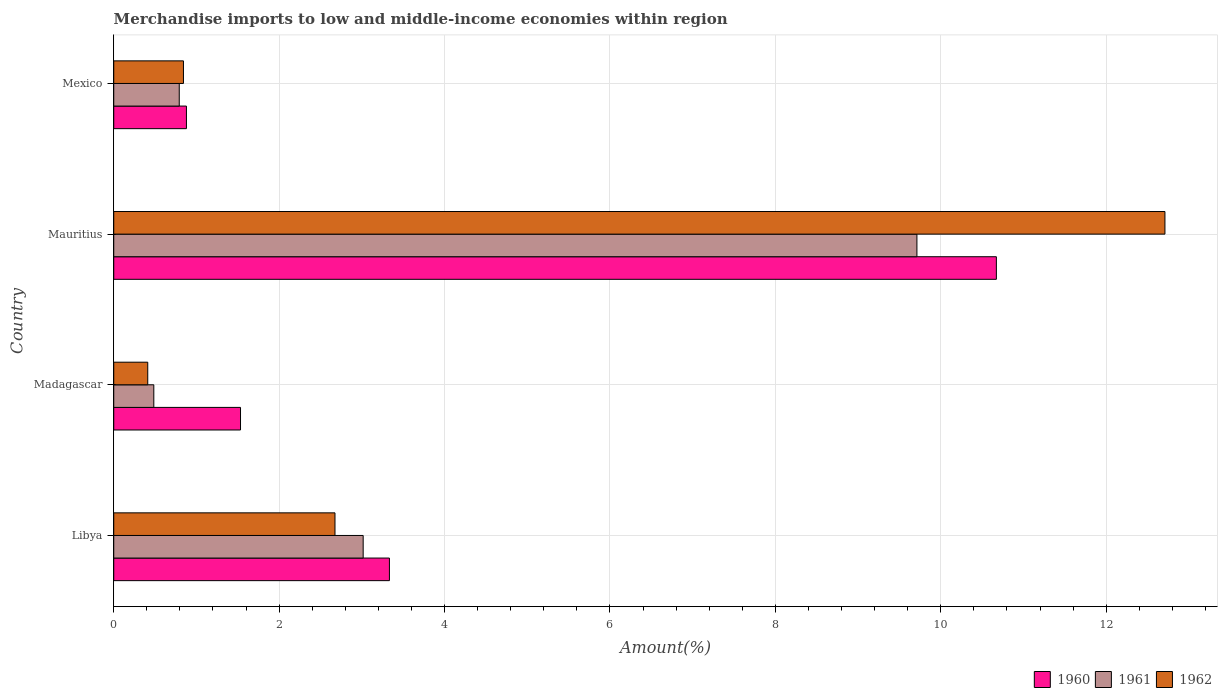How many groups of bars are there?
Offer a very short reply. 4. Are the number of bars per tick equal to the number of legend labels?
Your answer should be compact. Yes. Are the number of bars on each tick of the Y-axis equal?
Offer a very short reply. Yes. How many bars are there on the 4th tick from the top?
Your answer should be compact. 3. How many bars are there on the 4th tick from the bottom?
Provide a short and direct response. 3. What is the label of the 2nd group of bars from the top?
Your answer should be compact. Mauritius. In how many cases, is the number of bars for a given country not equal to the number of legend labels?
Keep it short and to the point. 0. What is the percentage of amount earned from merchandise imports in 1962 in Mexico?
Your response must be concise. 0.84. Across all countries, what is the maximum percentage of amount earned from merchandise imports in 1961?
Your answer should be very brief. 9.71. Across all countries, what is the minimum percentage of amount earned from merchandise imports in 1961?
Your answer should be very brief. 0.48. In which country was the percentage of amount earned from merchandise imports in 1960 maximum?
Provide a succinct answer. Mauritius. In which country was the percentage of amount earned from merchandise imports in 1960 minimum?
Your answer should be compact. Mexico. What is the total percentage of amount earned from merchandise imports in 1961 in the graph?
Offer a terse response. 14. What is the difference between the percentage of amount earned from merchandise imports in 1962 in Madagascar and that in Mauritius?
Your answer should be very brief. -12.3. What is the difference between the percentage of amount earned from merchandise imports in 1961 in Mauritius and the percentage of amount earned from merchandise imports in 1960 in Mexico?
Offer a very short reply. 8.83. What is the average percentage of amount earned from merchandise imports in 1961 per country?
Your answer should be very brief. 3.5. What is the difference between the percentage of amount earned from merchandise imports in 1962 and percentage of amount earned from merchandise imports in 1961 in Mexico?
Your answer should be compact. 0.05. In how many countries, is the percentage of amount earned from merchandise imports in 1960 greater than 6.8 %?
Your answer should be compact. 1. What is the ratio of the percentage of amount earned from merchandise imports in 1961 in Libya to that in Madagascar?
Provide a short and direct response. 6.23. Is the percentage of amount earned from merchandise imports in 1962 in Mauritius less than that in Mexico?
Give a very brief answer. No. Is the difference between the percentage of amount earned from merchandise imports in 1962 in Libya and Madagascar greater than the difference between the percentage of amount earned from merchandise imports in 1961 in Libya and Madagascar?
Offer a terse response. No. What is the difference between the highest and the second highest percentage of amount earned from merchandise imports in 1962?
Ensure brevity in your answer.  10.04. What is the difference between the highest and the lowest percentage of amount earned from merchandise imports in 1962?
Keep it short and to the point. 12.3. Is the sum of the percentage of amount earned from merchandise imports in 1962 in Mauritius and Mexico greater than the maximum percentage of amount earned from merchandise imports in 1961 across all countries?
Keep it short and to the point. Yes. What does the 3rd bar from the top in Libya represents?
Keep it short and to the point. 1960. What does the 1st bar from the bottom in Libya represents?
Your answer should be compact. 1960. Are all the bars in the graph horizontal?
Your answer should be compact. Yes. What is the difference between two consecutive major ticks on the X-axis?
Make the answer very short. 2. Are the values on the major ticks of X-axis written in scientific E-notation?
Your answer should be compact. No. Does the graph contain any zero values?
Offer a very short reply. No. Where does the legend appear in the graph?
Offer a terse response. Bottom right. How many legend labels are there?
Keep it short and to the point. 3. What is the title of the graph?
Your response must be concise. Merchandise imports to low and middle-income economies within region. What is the label or title of the X-axis?
Ensure brevity in your answer.  Amount(%). What is the Amount(%) of 1960 in Libya?
Your answer should be compact. 3.33. What is the Amount(%) of 1961 in Libya?
Make the answer very short. 3.02. What is the Amount(%) of 1962 in Libya?
Your response must be concise. 2.68. What is the Amount(%) of 1960 in Madagascar?
Provide a succinct answer. 1.53. What is the Amount(%) in 1961 in Madagascar?
Give a very brief answer. 0.48. What is the Amount(%) in 1962 in Madagascar?
Make the answer very short. 0.41. What is the Amount(%) of 1960 in Mauritius?
Give a very brief answer. 10.67. What is the Amount(%) in 1961 in Mauritius?
Your answer should be compact. 9.71. What is the Amount(%) of 1962 in Mauritius?
Your response must be concise. 12.71. What is the Amount(%) of 1960 in Mexico?
Your response must be concise. 0.88. What is the Amount(%) of 1961 in Mexico?
Ensure brevity in your answer.  0.79. What is the Amount(%) of 1962 in Mexico?
Offer a very short reply. 0.84. Across all countries, what is the maximum Amount(%) in 1960?
Provide a succinct answer. 10.67. Across all countries, what is the maximum Amount(%) in 1961?
Your answer should be compact. 9.71. Across all countries, what is the maximum Amount(%) in 1962?
Offer a very short reply. 12.71. Across all countries, what is the minimum Amount(%) of 1960?
Provide a short and direct response. 0.88. Across all countries, what is the minimum Amount(%) in 1961?
Offer a terse response. 0.48. Across all countries, what is the minimum Amount(%) in 1962?
Make the answer very short. 0.41. What is the total Amount(%) in 1960 in the graph?
Your answer should be very brief. 16.42. What is the total Amount(%) in 1961 in the graph?
Make the answer very short. 14. What is the total Amount(%) of 1962 in the graph?
Your answer should be very brief. 16.64. What is the difference between the Amount(%) in 1960 in Libya and that in Madagascar?
Give a very brief answer. 1.8. What is the difference between the Amount(%) of 1961 in Libya and that in Madagascar?
Your response must be concise. 2.53. What is the difference between the Amount(%) of 1962 in Libya and that in Madagascar?
Your answer should be very brief. 2.26. What is the difference between the Amount(%) in 1960 in Libya and that in Mauritius?
Ensure brevity in your answer.  -7.34. What is the difference between the Amount(%) in 1961 in Libya and that in Mauritius?
Make the answer very short. -6.7. What is the difference between the Amount(%) of 1962 in Libya and that in Mauritius?
Offer a terse response. -10.04. What is the difference between the Amount(%) of 1960 in Libya and that in Mexico?
Your response must be concise. 2.45. What is the difference between the Amount(%) of 1961 in Libya and that in Mexico?
Offer a very short reply. 2.22. What is the difference between the Amount(%) of 1962 in Libya and that in Mexico?
Keep it short and to the point. 1.83. What is the difference between the Amount(%) in 1960 in Madagascar and that in Mauritius?
Your answer should be compact. -9.14. What is the difference between the Amount(%) of 1961 in Madagascar and that in Mauritius?
Your answer should be very brief. -9.23. What is the difference between the Amount(%) in 1962 in Madagascar and that in Mauritius?
Offer a terse response. -12.3. What is the difference between the Amount(%) in 1960 in Madagascar and that in Mexico?
Offer a very short reply. 0.65. What is the difference between the Amount(%) in 1961 in Madagascar and that in Mexico?
Provide a short and direct response. -0.31. What is the difference between the Amount(%) in 1962 in Madagascar and that in Mexico?
Your response must be concise. -0.43. What is the difference between the Amount(%) of 1960 in Mauritius and that in Mexico?
Your response must be concise. 9.79. What is the difference between the Amount(%) of 1961 in Mauritius and that in Mexico?
Your response must be concise. 8.92. What is the difference between the Amount(%) in 1962 in Mauritius and that in Mexico?
Give a very brief answer. 11.87. What is the difference between the Amount(%) of 1960 in Libya and the Amount(%) of 1961 in Madagascar?
Your answer should be very brief. 2.85. What is the difference between the Amount(%) in 1960 in Libya and the Amount(%) in 1962 in Madagascar?
Ensure brevity in your answer.  2.92. What is the difference between the Amount(%) in 1961 in Libya and the Amount(%) in 1962 in Madagascar?
Provide a short and direct response. 2.6. What is the difference between the Amount(%) of 1960 in Libya and the Amount(%) of 1961 in Mauritius?
Keep it short and to the point. -6.38. What is the difference between the Amount(%) of 1960 in Libya and the Amount(%) of 1962 in Mauritius?
Give a very brief answer. -9.38. What is the difference between the Amount(%) of 1961 in Libya and the Amount(%) of 1962 in Mauritius?
Your answer should be very brief. -9.69. What is the difference between the Amount(%) in 1960 in Libya and the Amount(%) in 1961 in Mexico?
Provide a short and direct response. 2.54. What is the difference between the Amount(%) of 1960 in Libya and the Amount(%) of 1962 in Mexico?
Provide a short and direct response. 2.49. What is the difference between the Amount(%) of 1961 in Libya and the Amount(%) of 1962 in Mexico?
Your answer should be compact. 2.17. What is the difference between the Amount(%) in 1960 in Madagascar and the Amount(%) in 1961 in Mauritius?
Make the answer very short. -8.18. What is the difference between the Amount(%) of 1960 in Madagascar and the Amount(%) of 1962 in Mauritius?
Provide a short and direct response. -11.18. What is the difference between the Amount(%) of 1961 in Madagascar and the Amount(%) of 1962 in Mauritius?
Your answer should be compact. -12.23. What is the difference between the Amount(%) of 1960 in Madagascar and the Amount(%) of 1961 in Mexico?
Give a very brief answer. 0.74. What is the difference between the Amount(%) of 1960 in Madagascar and the Amount(%) of 1962 in Mexico?
Give a very brief answer. 0.69. What is the difference between the Amount(%) in 1961 in Madagascar and the Amount(%) in 1962 in Mexico?
Your answer should be very brief. -0.36. What is the difference between the Amount(%) of 1960 in Mauritius and the Amount(%) of 1961 in Mexico?
Provide a short and direct response. 9.88. What is the difference between the Amount(%) in 1960 in Mauritius and the Amount(%) in 1962 in Mexico?
Provide a short and direct response. 9.83. What is the difference between the Amount(%) in 1961 in Mauritius and the Amount(%) in 1962 in Mexico?
Ensure brevity in your answer.  8.87. What is the average Amount(%) of 1960 per country?
Offer a terse response. 4.1. What is the average Amount(%) in 1961 per country?
Your answer should be compact. 3.5. What is the average Amount(%) of 1962 per country?
Offer a very short reply. 4.16. What is the difference between the Amount(%) in 1960 and Amount(%) in 1961 in Libya?
Your answer should be compact. 0.32. What is the difference between the Amount(%) of 1960 and Amount(%) of 1962 in Libya?
Make the answer very short. 0.66. What is the difference between the Amount(%) of 1961 and Amount(%) of 1962 in Libya?
Offer a terse response. 0.34. What is the difference between the Amount(%) in 1960 and Amount(%) in 1961 in Madagascar?
Ensure brevity in your answer.  1.05. What is the difference between the Amount(%) of 1960 and Amount(%) of 1962 in Madagascar?
Your answer should be very brief. 1.12. What is the difference between the Amount(%) of 1961 and Amount(%) of 1962 in Madagascar?
Provide a short and direct response. 0.07. What is the difference between the Amount(%) in 1960 and Amount(%) in 1961 in Mauritius?
Provide a short and direct response. 0.96. What is the difference between the Amount(%) of 1960 and Amount(%) of 1962 in Mauritius?
Your answer should be compact. -2.04. What is the difference between the Amount(%) of 1961 and Amount(%) of 1962 in Mauritius?
Your response must be concise. -3. What is the difference between the Amount(%) of 1960 and Amount(%) of 1961 in Mexico?
Give a very brief answer. 0.09. What is the difference between the Amount(%) of 1960 and Amount(%) of 1962 in Mexico?
Ensure brevity in your answer.  0.04. What is the difference between the Amount(%) of 1961 and Amount(%) of 1962 in Mexico?
Your response must be concise. -0.05. What is the ratio of the Amount(%) in 1960 in Libya to that in Madagascar?
Keep it short and to the point. 2.17. What is the ratio of the Amount(%) in 1961 in Libya to that in Madagascar?
Ensure brevity in your answer.  6.23. What is the ratio of the Amount(%) in 1962 in Libya to that in Madagascar?
Keep it short and to the point. 6.51. What is the ratio of the Amount(%) in 1960 in Libya to that in Mauritius?
Give a very brief answer. 0.31. What is the ratio of the Amount(%) of 1961 in Libya to that in Mauritius?
Give a very brief answer. 0.31. What is the ratio of the Amount(%) in 1962 in Libya to that in Mauritius?
Your answer should be compact. 0.21. What is the ratio of the Amount(%) of 1960 in Libya to that in Mexico?
Ensure brevity in your answer.  3.79. What is the ratio of the Amount(%) in 1961 in Libya to that in Mexico?
Make the answer very short. 3.81. What is the ratio of the Amount(%) of 1962 in Libya to that in Mexico?
Provide a short and direct response. 3.17. What is the ratio of the Amount(%) in 1960 in Madagascar to that in Mauritius?
Provide a short and direct response. 0.14. What is the ratio of the Amount(%) in 1961 in Madagascar to that in Mauritius?
Your answer should be compact. 0.05. What is the ratio of the Amount(%) in 1962 in Madagascar to that in Mauritius?
Your response must be concise. 0.03. What is the ratio of the Amount(%) of 1960 in Madagascar to that in Mexico?
Provide a succinct answer. 1.74. What is the ratio of the Amount(%) of 1961 in Madagascar to that in Mexico?
Give a very brief answer. 0.61. What is the ratio of the Amount(%) in 1962 in Madagascar to that in Mexico?
Provide a short and direct response. 0.49. What is the ratio of the Amount(%) of 1960 in Mauritius to that in Mexico?
Your answer should be very brief. 12.14. What is the ratio of the Amount(%) of 1961 in Mauritius to that in Mexico?
Make the answer very short. 12.26. What is the ratio of the Amount(%) in 1962 in Mauritius to that in Mexico?
Ensure brevity in your answer.  15.08. What is the difference between the highest and the second highest Amount(%) of 1960?
Make the answer very short. 7.34. What is the difference between the highest and the second highest Amount(%) of 1961?
Offer a very short reply. 6.7. What is the difference between the highest and the second highest Amount(%) of 1962?
Your answer should be compact. 10.04. What is the difference between the highest and the lowest Amount(%) in 1960?
Your response must be concise. 9.79. What is the difference between the highest and the lowest Amount(%) in 1961?
Give a very brief answer. 9.23. What is the difference between the highest and the lowest Amount(%) in 1962?
Your answer should be very brief. 12.3. 